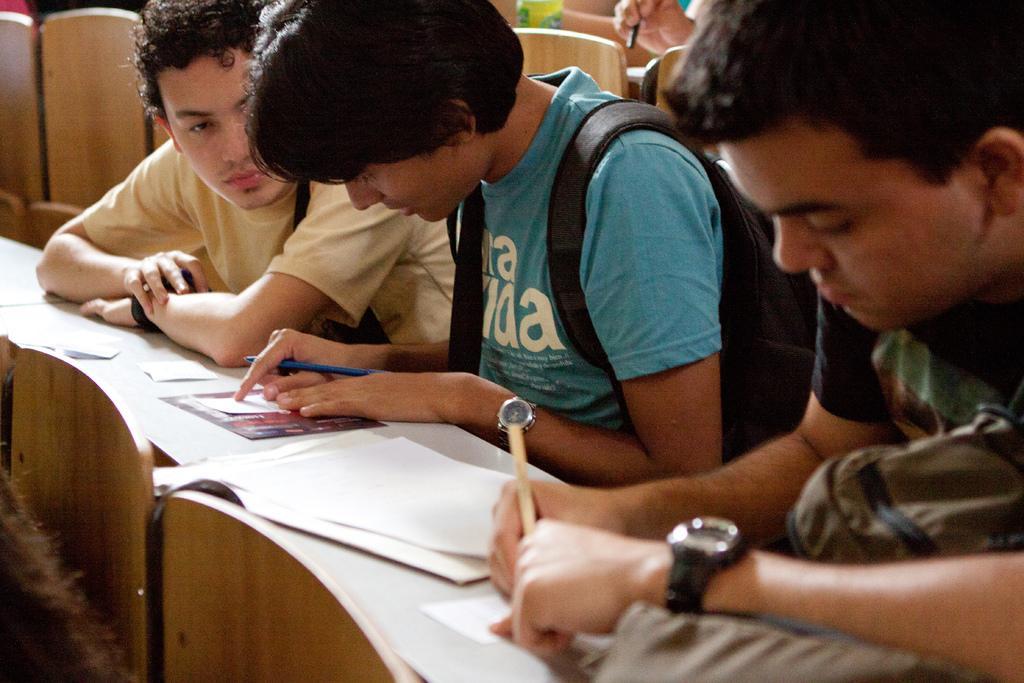Please provide a concise description of this image. In this image I can see few men are sitting and I can see the right two of them are holding pens. In the front of them I can see few papers and in the background I can see hand of a person and a bottle. 